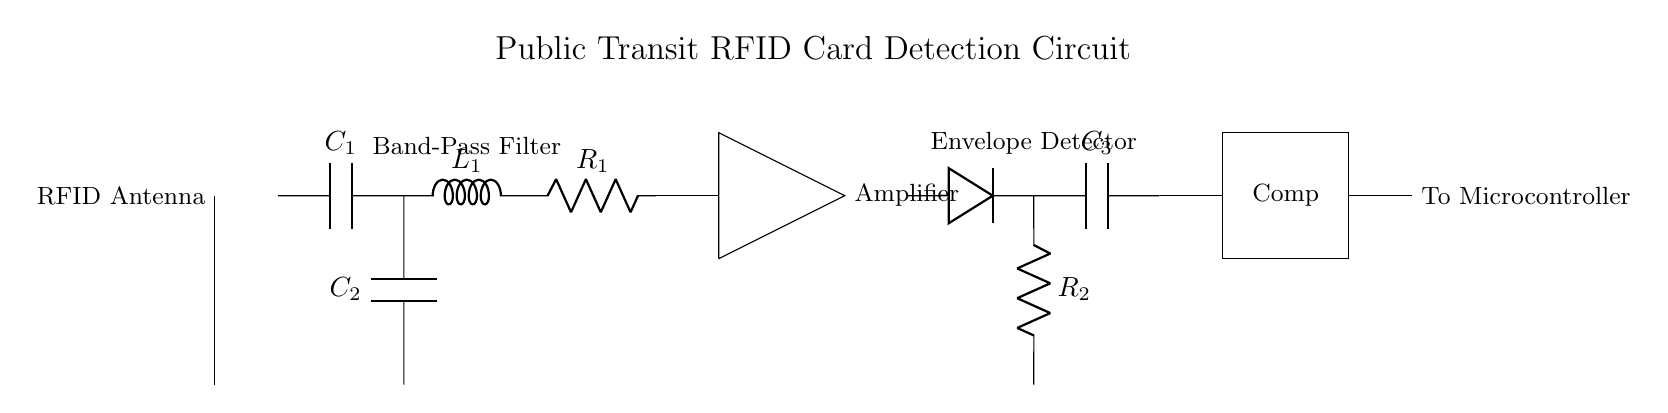What component is connected to the RFID antenna? The component connected to the RFID antenna is the band-pass filter, which is represented by the combination of capacitors, inductors, and resistors that form the filter circuit.
Answer: band-pass filter What type of filter is used in this circuit? This circuit employs a band-pass filter, which allows a specific range of frequencies to pass through while attenuating frequencies outside this range. This is crucial for detecting the RFID signals.
Answer: band-pass filter What is the main purpose of the amplifier in this circuit? The amplifier boosts the signal received from the RFID antenna after it has passed through the band-pass filter, ensuring the signal strength is sufficient for further processing by the envelope detector and comparator.
Answer: signal boosting How many capacitors are present in the band-pass filter section? There are two capacitors present in the band-pass filter section: C1 and C2. These components are essential for defining the frequency response of the filter.
Answer: two What component follows the envelope detector in this circuit? The component that follows the envelope detector is the comparator, which compares the processed signal against a reference voltage to determine if it meets the criteria for a valid RFID signal.
Answer: comparator What type of circuit is represented in this diagram? The diagram represents an RFID card detection circuit that incorporates various components such as a band-pass filter, amplifier, envelope detector, and comparator, tailored for detecting RFID signals in public transit ticketing systems.
Answer: RFID card detection circuit 